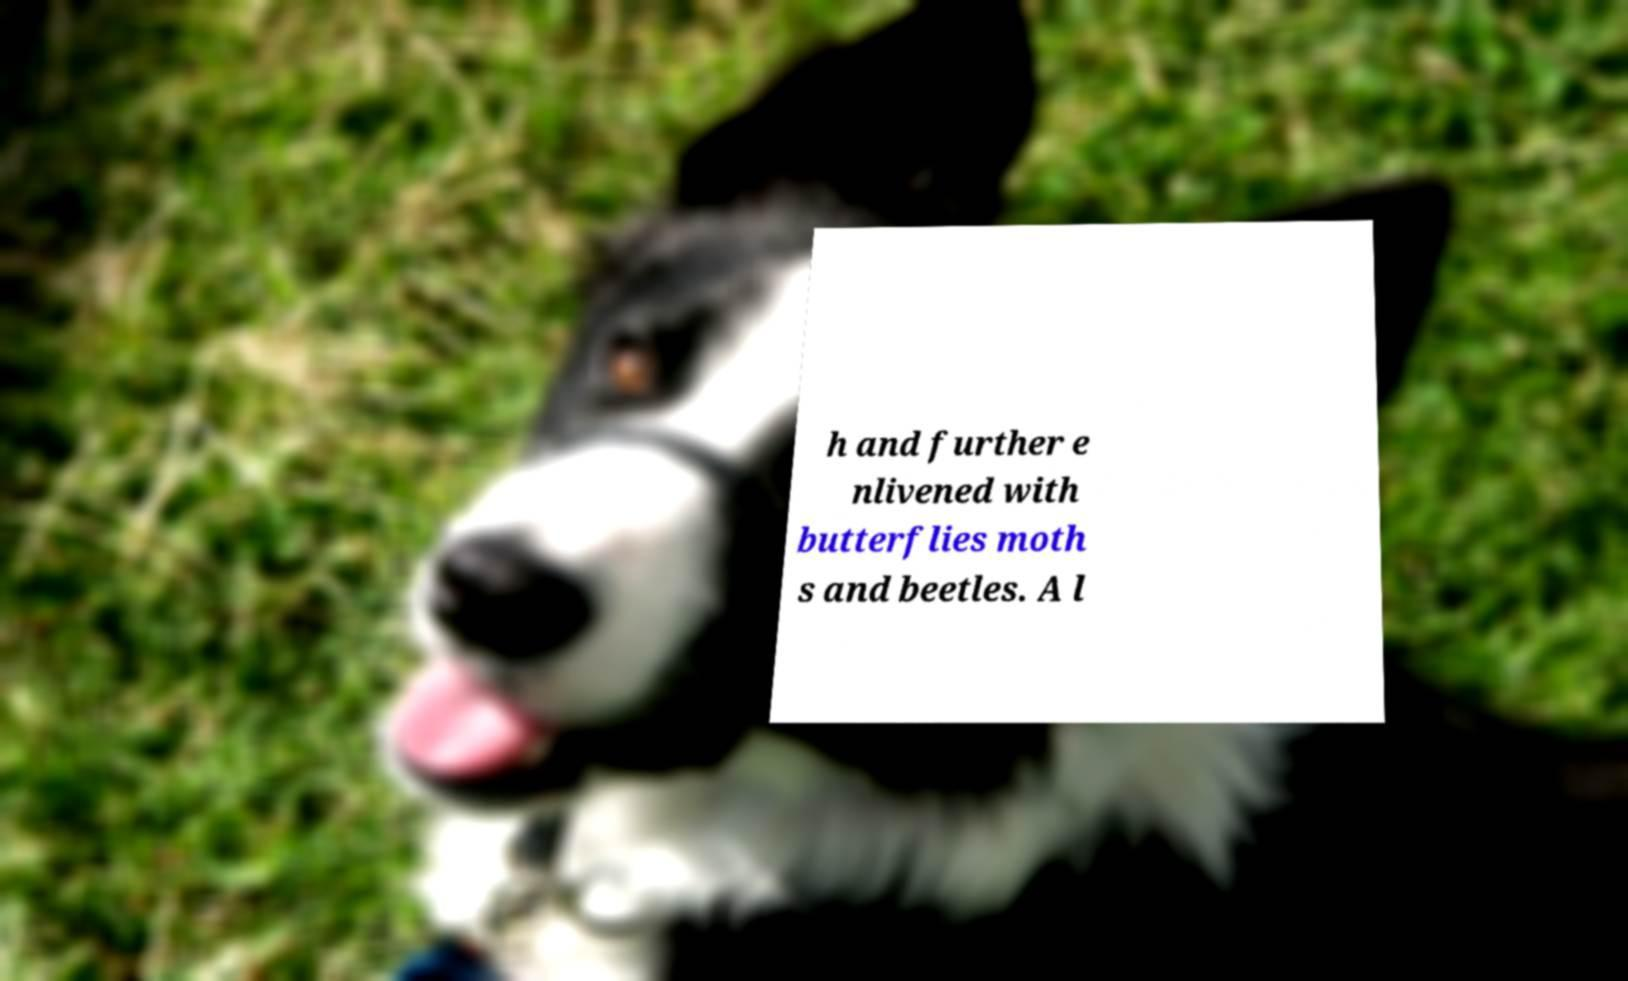What messages or text are displayed in this image? I need them in a readable, typed format. h and further e nlivened with butterflies moth s and beetles. A l 